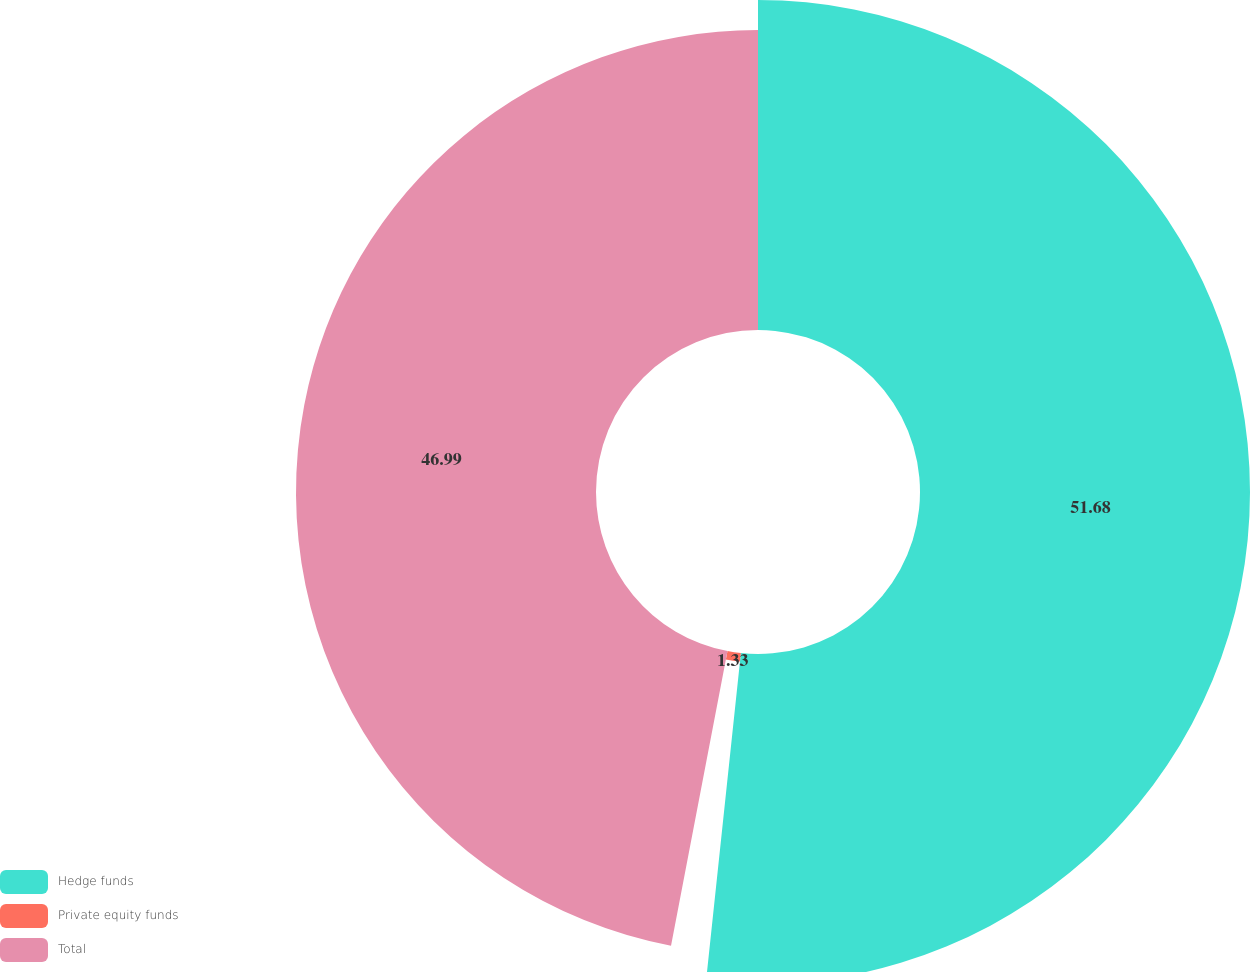<chart> <loc_0><loc_0><loc_500><loc_500><pie_chart><fcel>Hedge funds<fcel>Private equity funds<fcel>Total<nl><fcel>51.69%<fcel>1.33%<fcel>46.99%<nl></chart> 